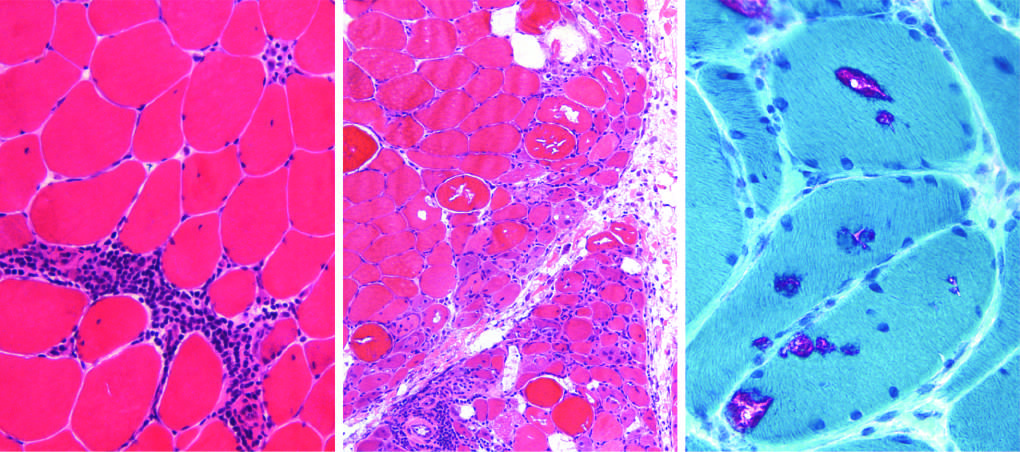what does dermatomyositis show?
Answer the question using a single word or phrase. Prominent perifascicular and paraseptal atrophy 